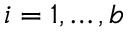<formula> <loc_0><loc_0><loc_500><loc_500>i = 1 , \dots , b</formula> 